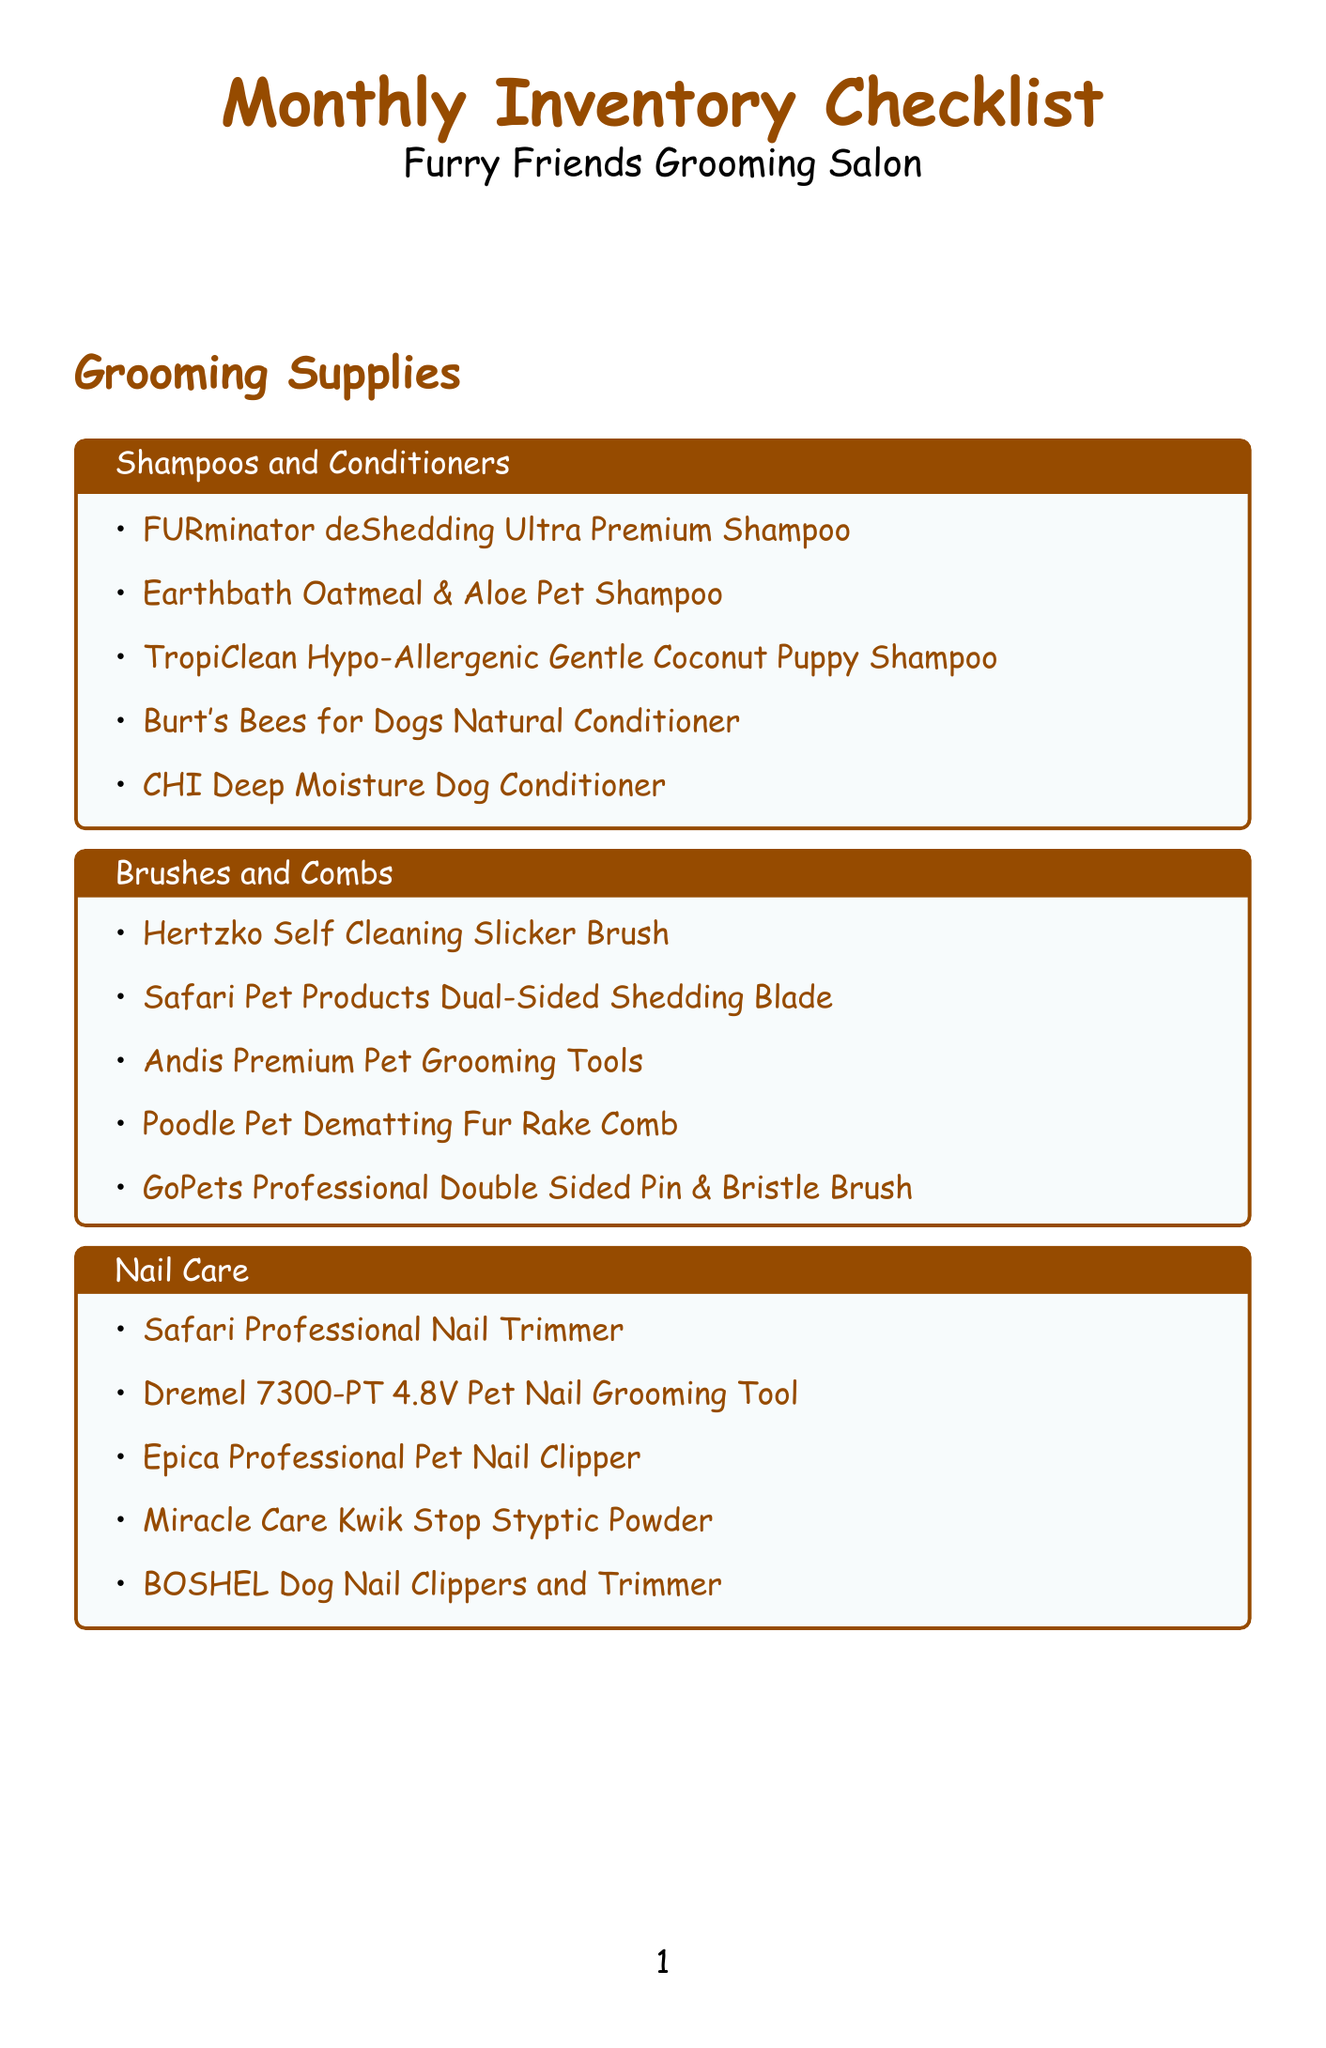What is the first item listed under Shampoos and Conditioners? The first item listed under Shampoos and Conditioners in the document is FURminator deShedding Ultra Premium Shampoo.
Answer: FURminator deShedding Ultra Premium Shampoo How many categories of cleaning products are there? The document lists four categories of cleaning products: Disinfectants, Odor Eliminators, Carpet Cleaners, and General Cleaning. Therefore, there are four categories.
Answer: 4 Which nail care item is also mentioned in the equipment maintenance section? The document does not list any overlapping items between the Nail Care and the Equipment Maintenance sections.
Answer: None What cleaning product is specifically labeled as an odor eliminator? The document lists Nature's Miracle Advanced Stain & Odor Eliminator as one of the odor eliminators.
Answer: Nature's Miracle Advanced Stain & Odor Eliminator How many items are listed under Ear and Eye Care? The document includes five items listed under Ear and Eye Care.
Answer: 5 Which grooming supply category has the most items listed? The document does not indicate the individual counts for each grooming supply category, but they each appear to have five items.
Answer: All have 5 What is the last item in the Carpet Cleaners section? The last item listed in the Carpet Cleaners section is Woolite Advanced Pet Stain & Odor Remover + Sanitize.
Answer: Woolite Advanced Pet Stain & Odor Remover + Sanitize Name one brand of the dryers listed in the Equipment Maintenance section. The document lists several brands, including K-9 III, Metro, and B-Air among the dryers.
Answer: K-9 III What type of equipment maintenance category does the Wysiwash Sanitizer-V belong to? The Wysiwash Sanitizer-V belongs to the Disinfectants category in the cleaning products section.
Answer: Disinfectants 